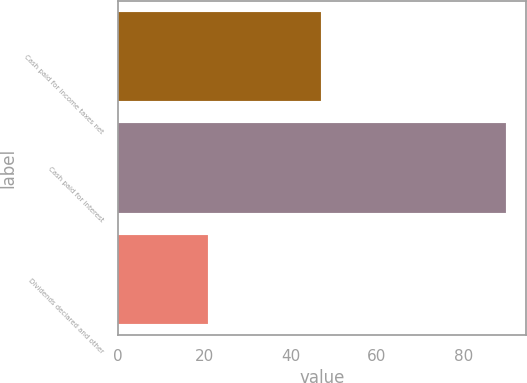Convert chart to OTSL. <chart><loc_0><loc_0><loc_500><loc_500><bar_chart><fcel>Cash paid for income taxes net<fcel>Cash paid for interest<fcel>Dividends declared and other<nl><fcel>47<fcel>90<fcel>21<nl></chart> 